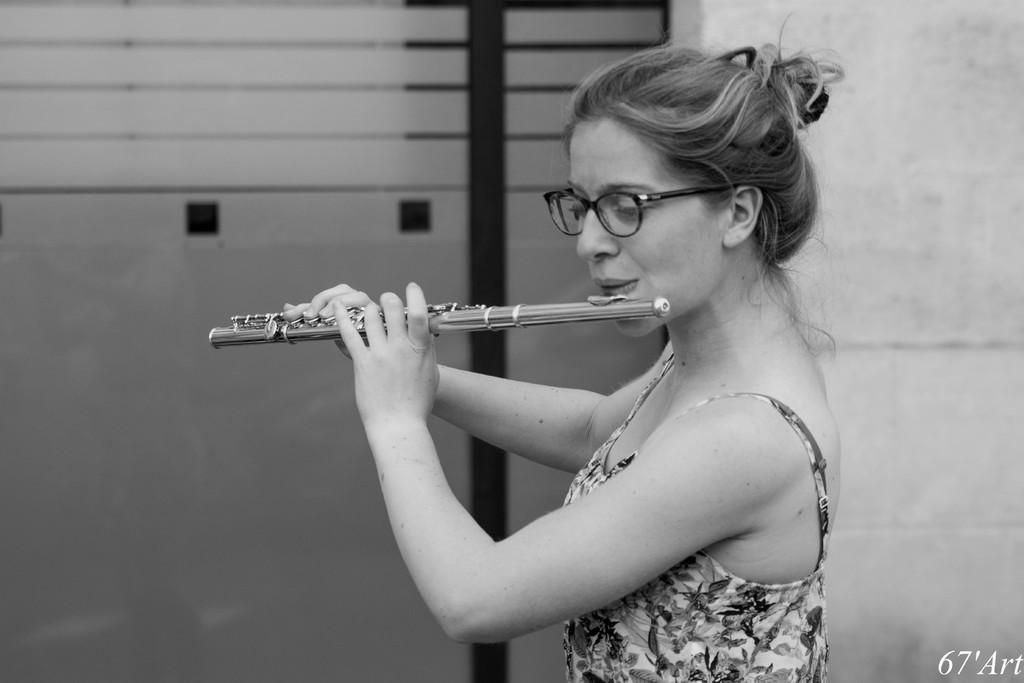Who is the main subject in the image? There is a woman in the image. What is the woman holding in the image? The woman is holding a musical instrument. What can be seen in the background of the image? There is a wall in the background of the image. Is there any text visible in the image? Yes, there is some text visible in the bottom right corner of the image. Can you tell me how many straws are being used by the bee in the image? There is no bee or straw present in the image. What type of vacation is the woman planning in the image? There is no indication of a vacation in the image; it simply shows a woman holding a musical instrument. 